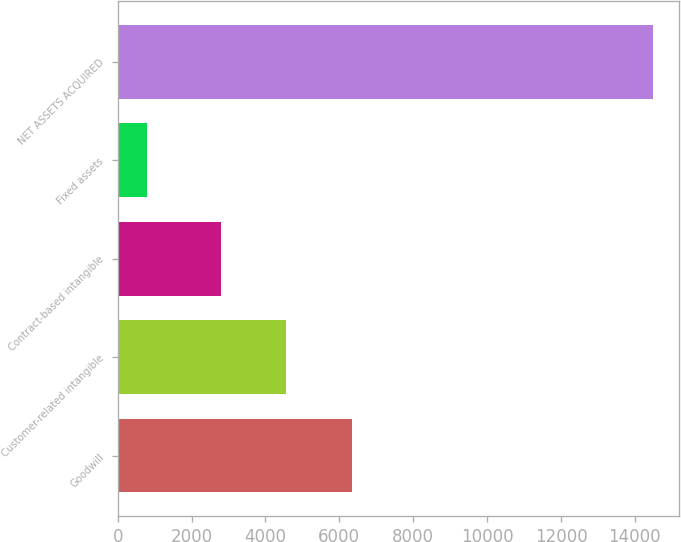Convert chart to OTSL. <chart><loc_0><loc_0><loc_500><loc_500><bar_chart><fcel>Goodwill<fcel>Customer-related intangible<fcel>Contract-based intangible<fcel>Fixed assets<fcel>NET ASSETS ACQUIRED<nl><fcel>6341<fcel>4543<fcel>2796<fcel>798<fcel>14478<nl></chart> 